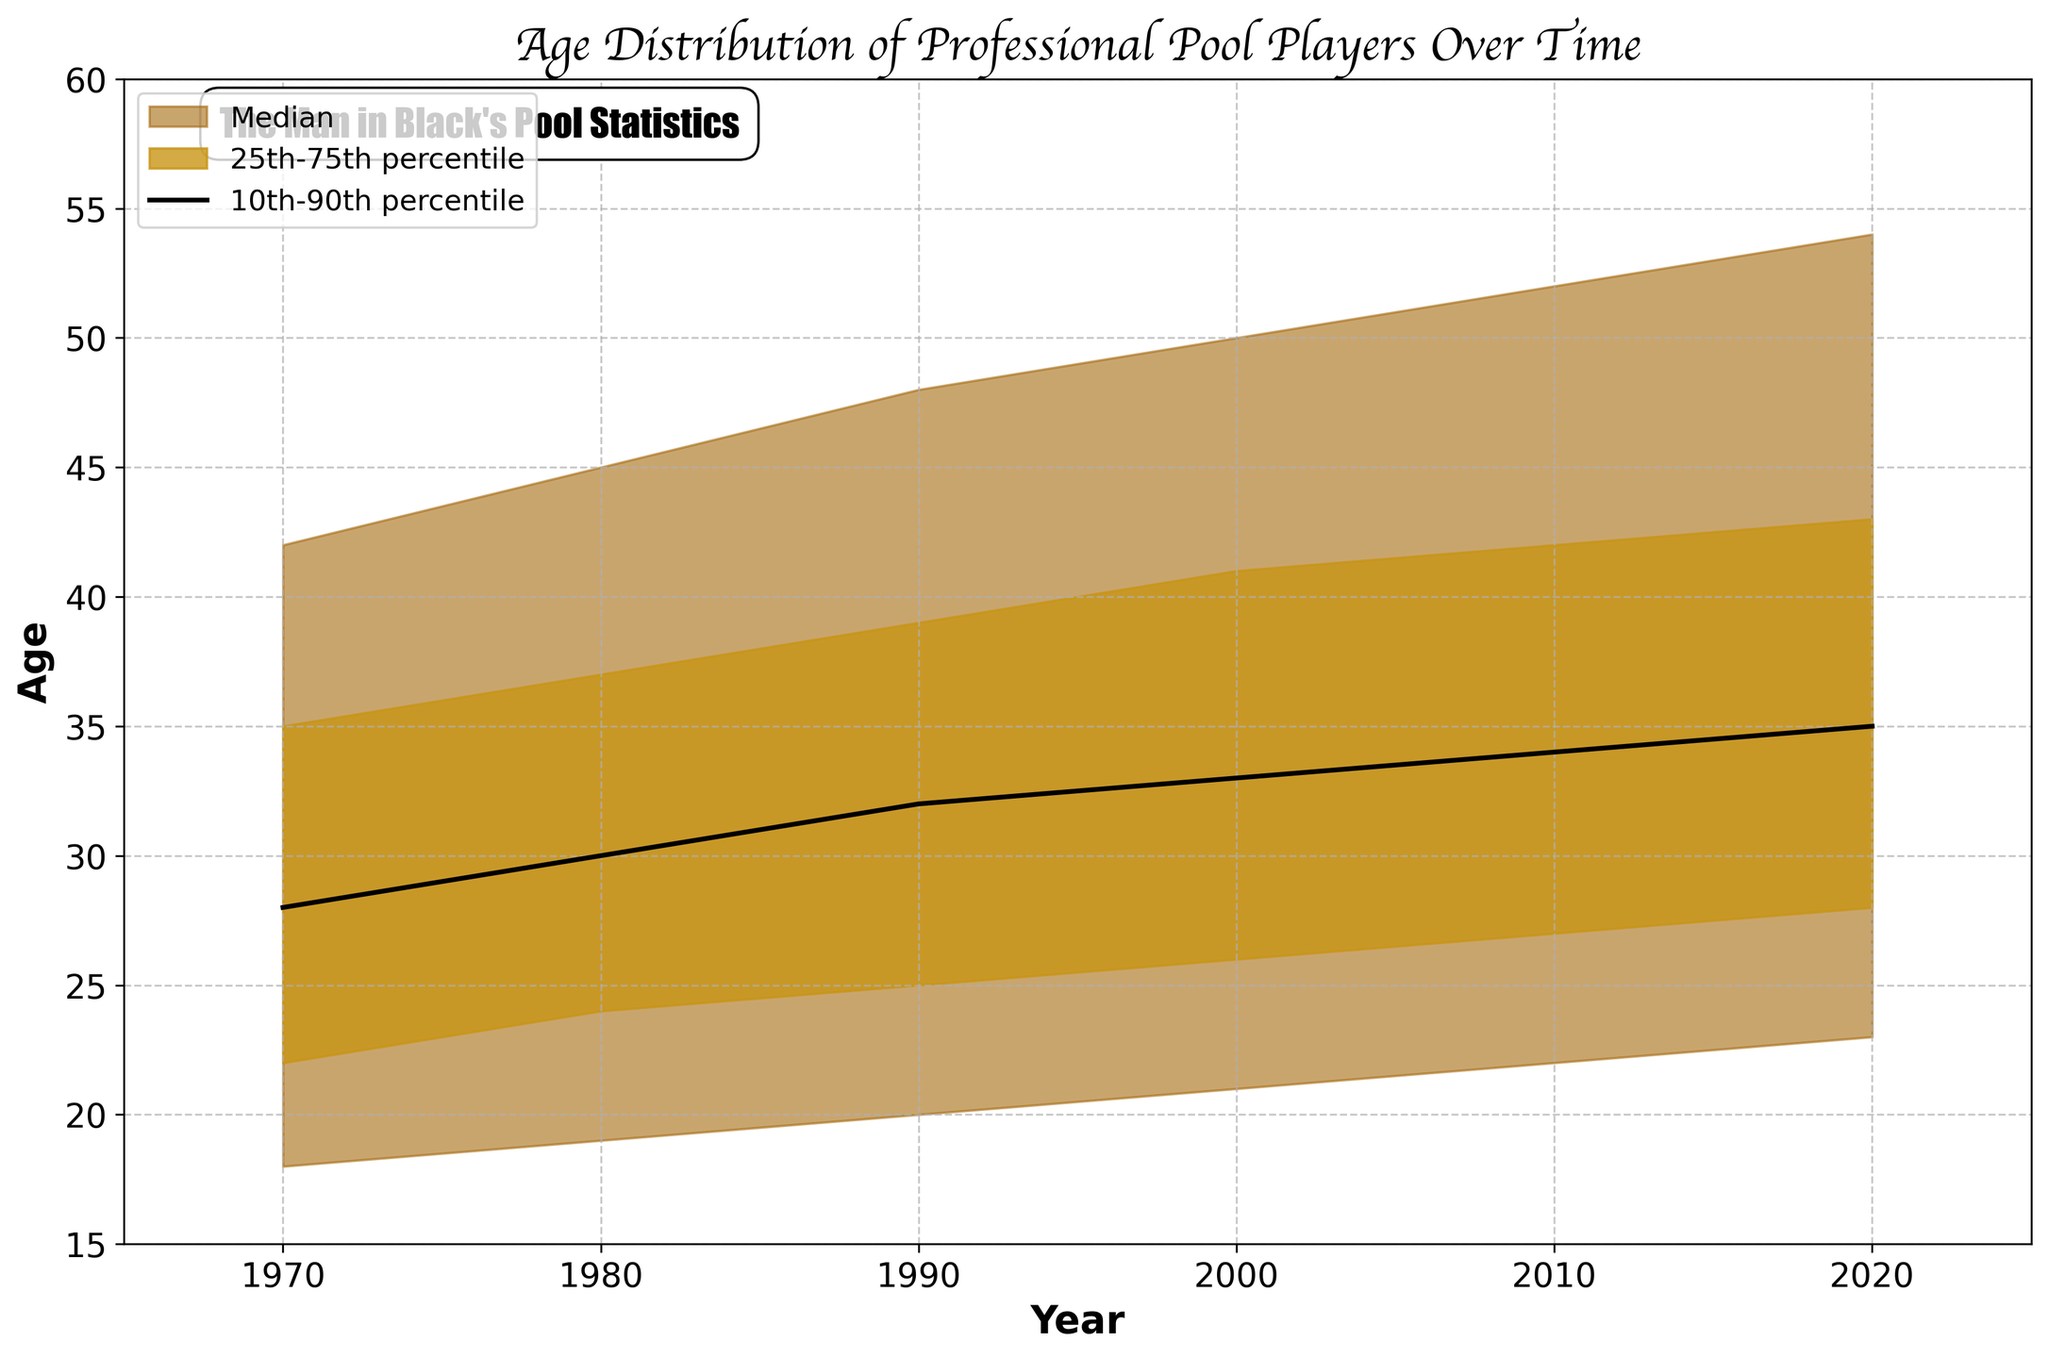What's the title of the chart? The title is usually placed at the top of the chart and helps identify the main subject. In this chart, the title is clearly written at the top.
Answer: Age Distribution of Professional Pool Players Over Time What does the 10th percentile line represent in the chart? The 10th percentile line indicates that 10% of professional pool players are younger than the value on this line in any given year.
Answer: The age below which 10% of the players fall How has the median age of professional pool players changed from 1970 to 2020? The median age is represented by the black line in the plot. We can track its position from 1970 to 2020 to observe the change.
Answer: Increased from 28 to 35 What is the age range between the 25th and 75th percentile in the year 2000? The range can be calculated by subtracting the 25th percentile value from the 75th percentile value for the year 2000.
Answer: 15 years (41 - 26) Which year shows the highest value for the 90th percentile? Check the 90th percentile line (the topmost line) and identify the highest value over the years.
Answer: 2020 Comparing 1990 to 2010, how much did the median age increase? Subtract the median age in 1990 from the median age in 2010.
Answer: 2 years (34 - 32) What's the age difference between the 10th percentile and the 90th percentile in the year 1980? The age difference is found by subtracting the 10th percentile value from the 90th percentile value in 1980.
Answer: 26 years (45 - 19) Between which years did the 75th percentile exceed 40 years for the first time? Locate the point in the chart where the 75th percentile line crosses 40 years and identify the corresponding years.
Answer: Between 1990 and 2000 What can you say about the overall trend of the age distribution of professional pool players over time? Examine the lines representing different percentiles to infer the trend. The lines show a general increase in age over time.
Answer: Increasing trend 